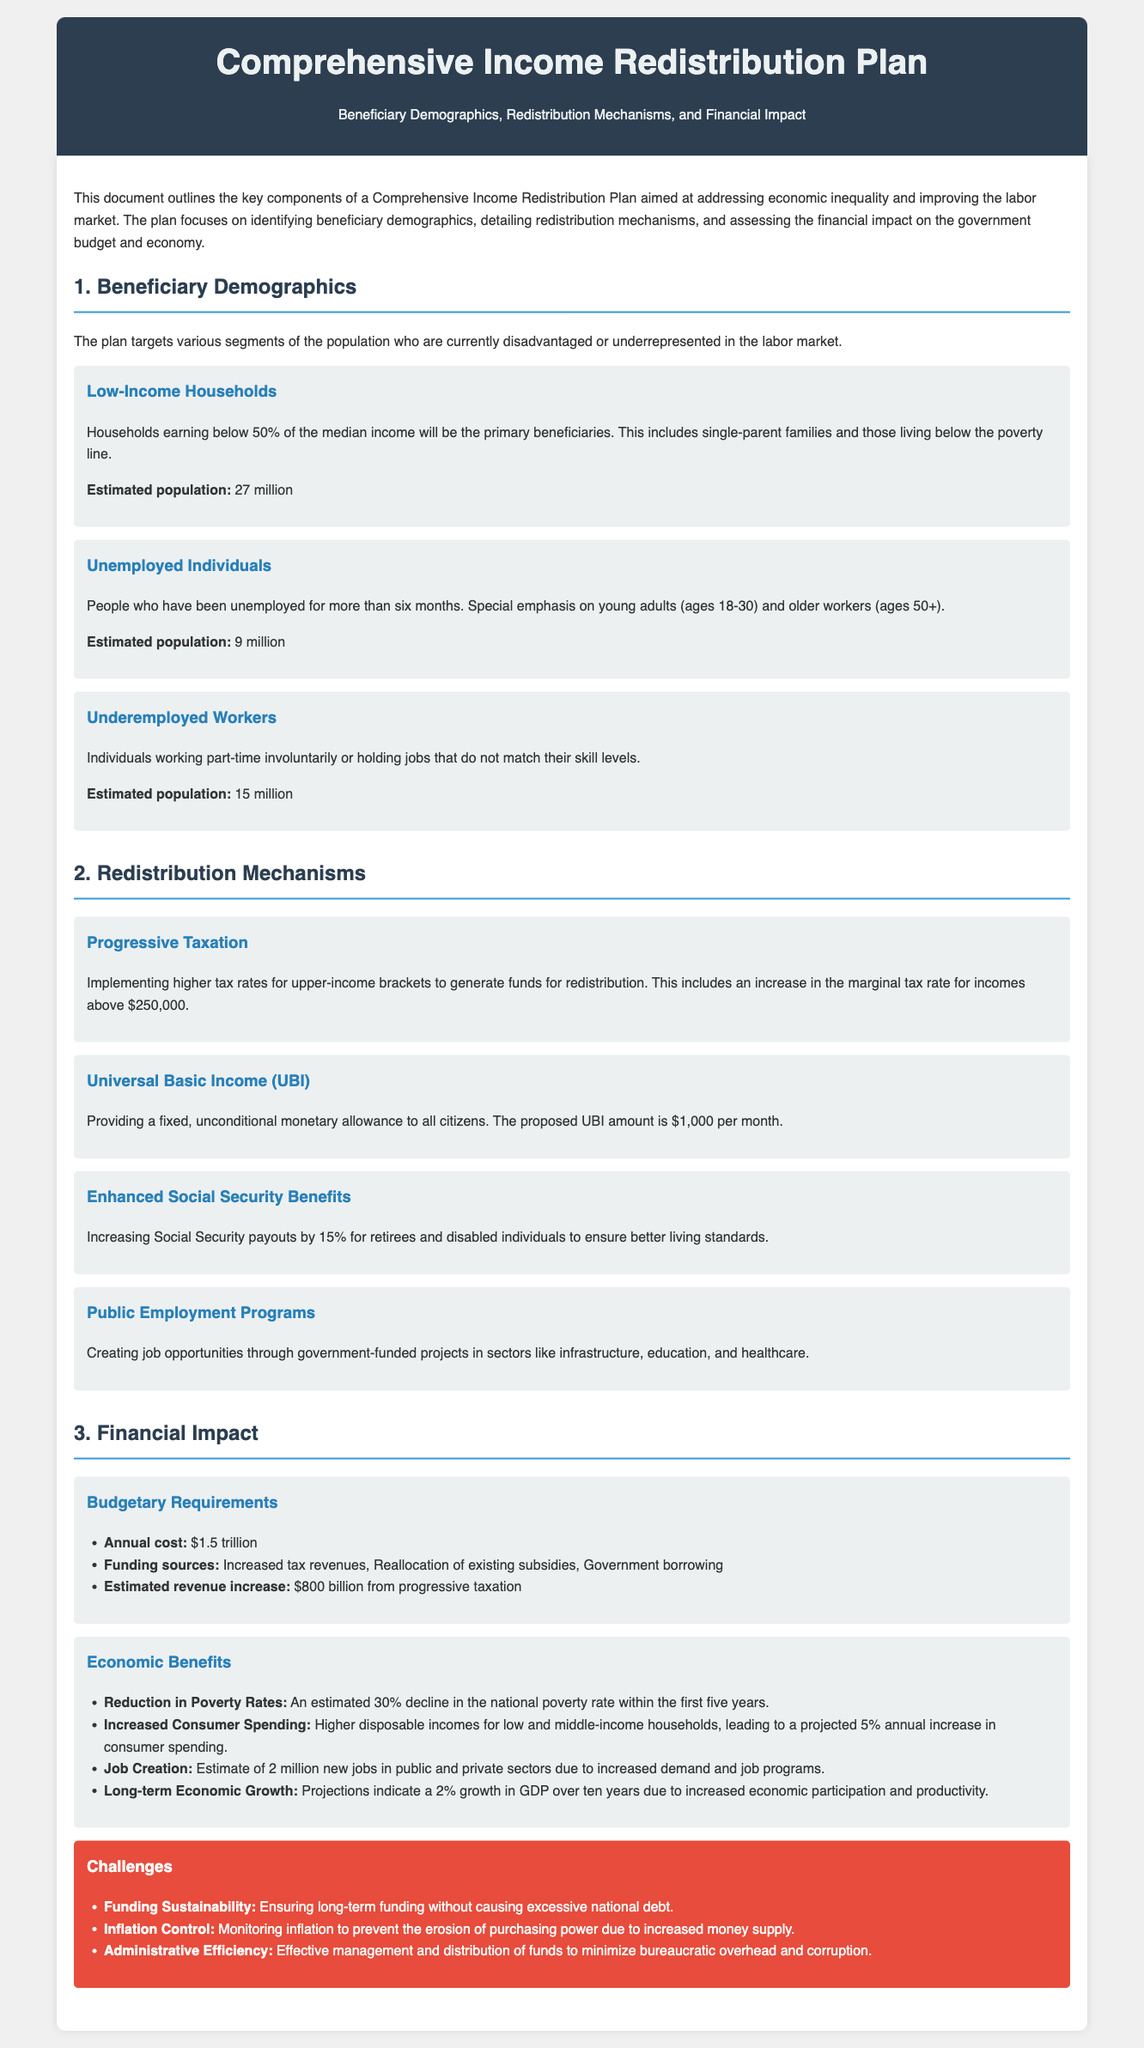What is the estimated population of low-income households? The estimated population of low-income households is provided in the document, which states it is 27 million.
Answer: 27 million What is the proposed Universal Basic Income (UBI) amount? The document specifies that the proposed UBI amount is a fixed amount provided to all citizens, which is stated to be $1,000 per month.
Answer: $1,000 per month How much is the annual cost of the Comprehensive Income Redistribution Plan? The document mentions that the annual cost of the plan is mentioned in the financial impact section, which is $1.5 trillion.
Answer: $1.5 trillion What percentage increase is projected for consumer spending? The document indicates that higher disposable incomes for households will lead to a projected increase in consumer spending of 5% annually.
Answer: 5% What are the primary beneficiaries of the plan according to the demographics? Low-income households are identified as the primary beneficiaries in the document.
Answer: Low-income households What challenge is related to inflation control? The challenges section in the document discusses concerns about monitoring inflation, which is identified as a challenge to be addressed.
Answer: Inflation Control What type of taxation is proposed in the redistribution mechanisms? The document details that progressive taxation is the proposed mechanism to generate funds for redistribution.
Answer: Progressive Taxation How many new jobs are estimated to be created due to the plan? According to the economic benefits section, the estimated number of new jobs created is 2 million.
Answer: 2 million What is one funding source mentioned for the budgetary requirements? The document lists increased tax revenues as one of the funding sources to meet the budgetary requirements of the plan.
Answer: Increased tax revenues 